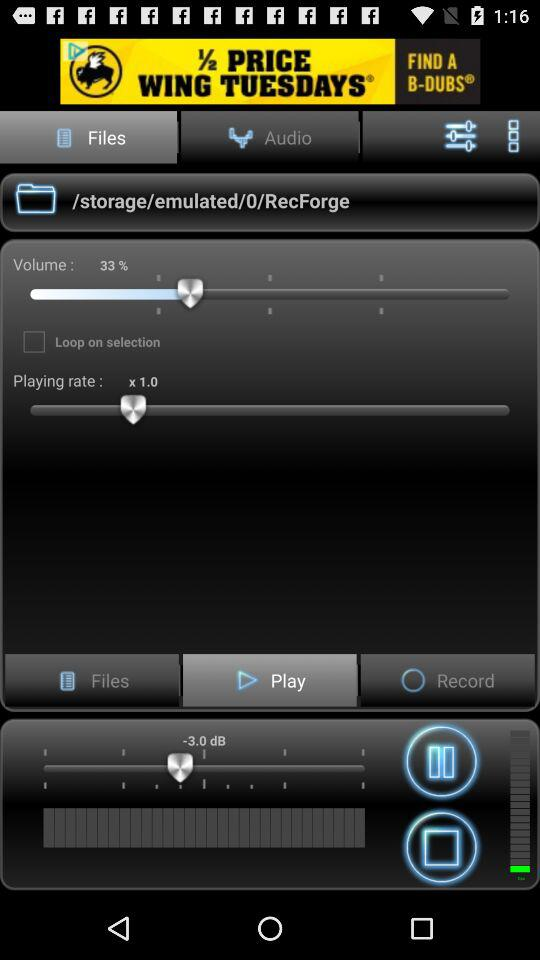What is the volume percentage? The volume percentage is 33. 